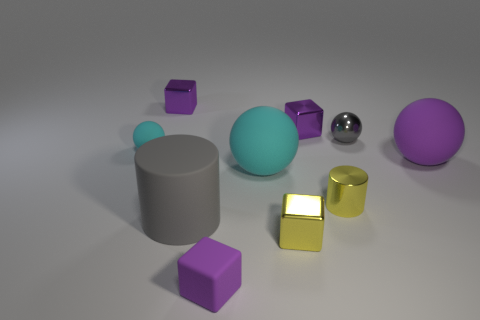Subtract all purple blocks. How many were subtracted if there are1purple blocks left? 2 Subtract all red balls. How many purple blocks are left? 3 Subtract all cylinders. How many objects are left? 8 Subtract 1 gray cylinders. How many objects are left? 9 Subtract all purple rubber balls. Subtract all tiny shiny cylinders. How many objects are left? 8 Add 5 small matte spheres. How many small matte spheres are left? 6 Add 7 small cyan rubber objects. How many small cyan rubber objects exist? 8 